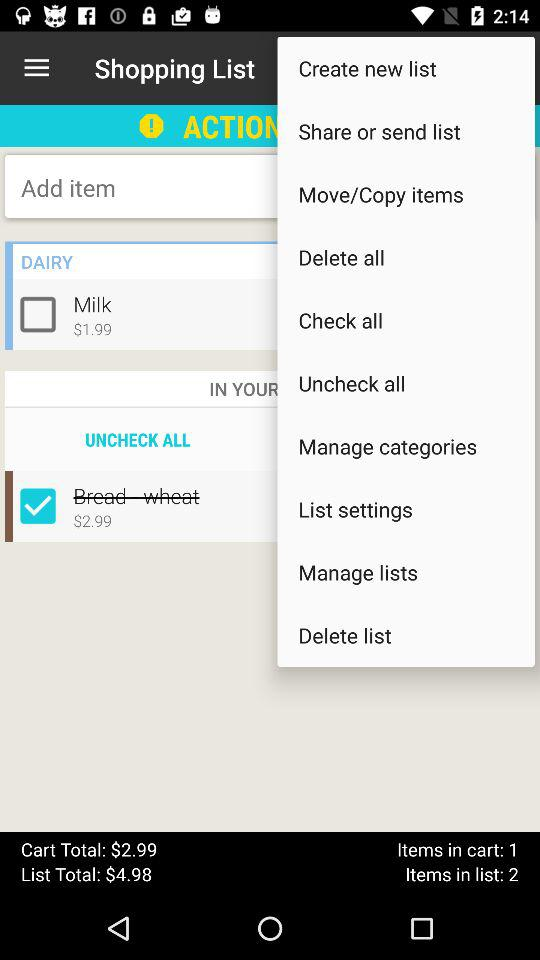What is the total cart amount? The amount is $2.99. 